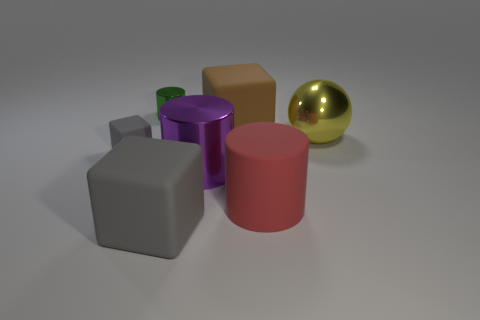What is the material of the cylinder that is both in front of the big yellow metal thing and on the left side of the big brown rubber object?
Keep it short and to the point. Metal. What is the material of the other large thing that is the same shape as the brown object?
Ensure brevity in your answer.  Rubber. There is a gray object that is behind the large purple metallic cylinder to the right of the tiny shiny cylinder; how many red cylinders are to the right of it?
Offer a terse response. 1. Is there anything else of the same color as the rubber cylinder?
Offer a terse response. No. How many large shiny things are both on the left side of the metal ball and on the right side of the red cylinder?
Keep it short and to the point. 0. There is a gray matte thing to the left of the green thing; does it have the same size as the cylinder that is behind the brown rubber object?
Keep it short and to the point. Yes. How many things are matte things on the left side of the large brown matte block or big yellow metal spheres?
Keep it short and to the point. 3. What is the big gray cube in front of the large red matte cylinder made of?
Provide a short and direct response. Rubber. What is the ball made of?
Ensure brevity in your answer.  Metal. What is the material of the large cylinder to the left of the rubber object that is behind the gray thing behind the large red thing?
Keep it short and to the point. Metal. 